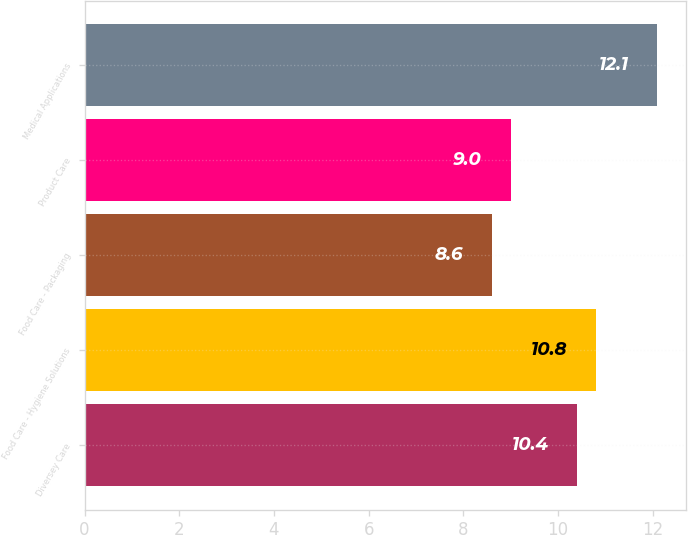<chart> <loc_0><loc_0><loc_500><loc_500><bar_chart><fcel>Diversey Care<fcel>Food Care - Hygiene Solutions<fcel>Food Care - Packaging<fcel>Product Care<fcel>Medical Applications<nl><fcel>10.4<fcel>10.8<fcel>8.6<fcel>9<fcel>12.1<nl></chart> 